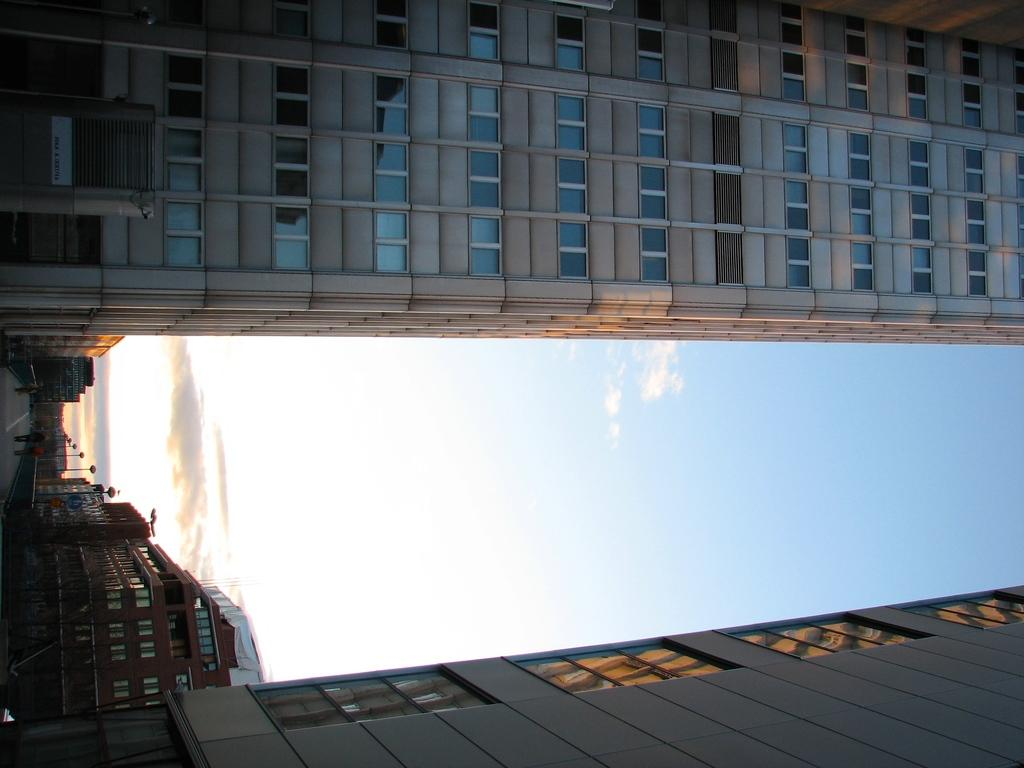What are the people in the image doing? The people in the image are walking on the road. What can be seen illuminating the road in the image? There are street lights in the image. What is visible in the background of the image? There are buildings and the sky in the background of the image. How many clover leaves can be seen growing on the street lights in the image? There are no clover leaves present on the street lights in the image. What type of rings are the people wearing on their fingers in the image? There is no information about rings or any jewelry worn by the people in the image. 